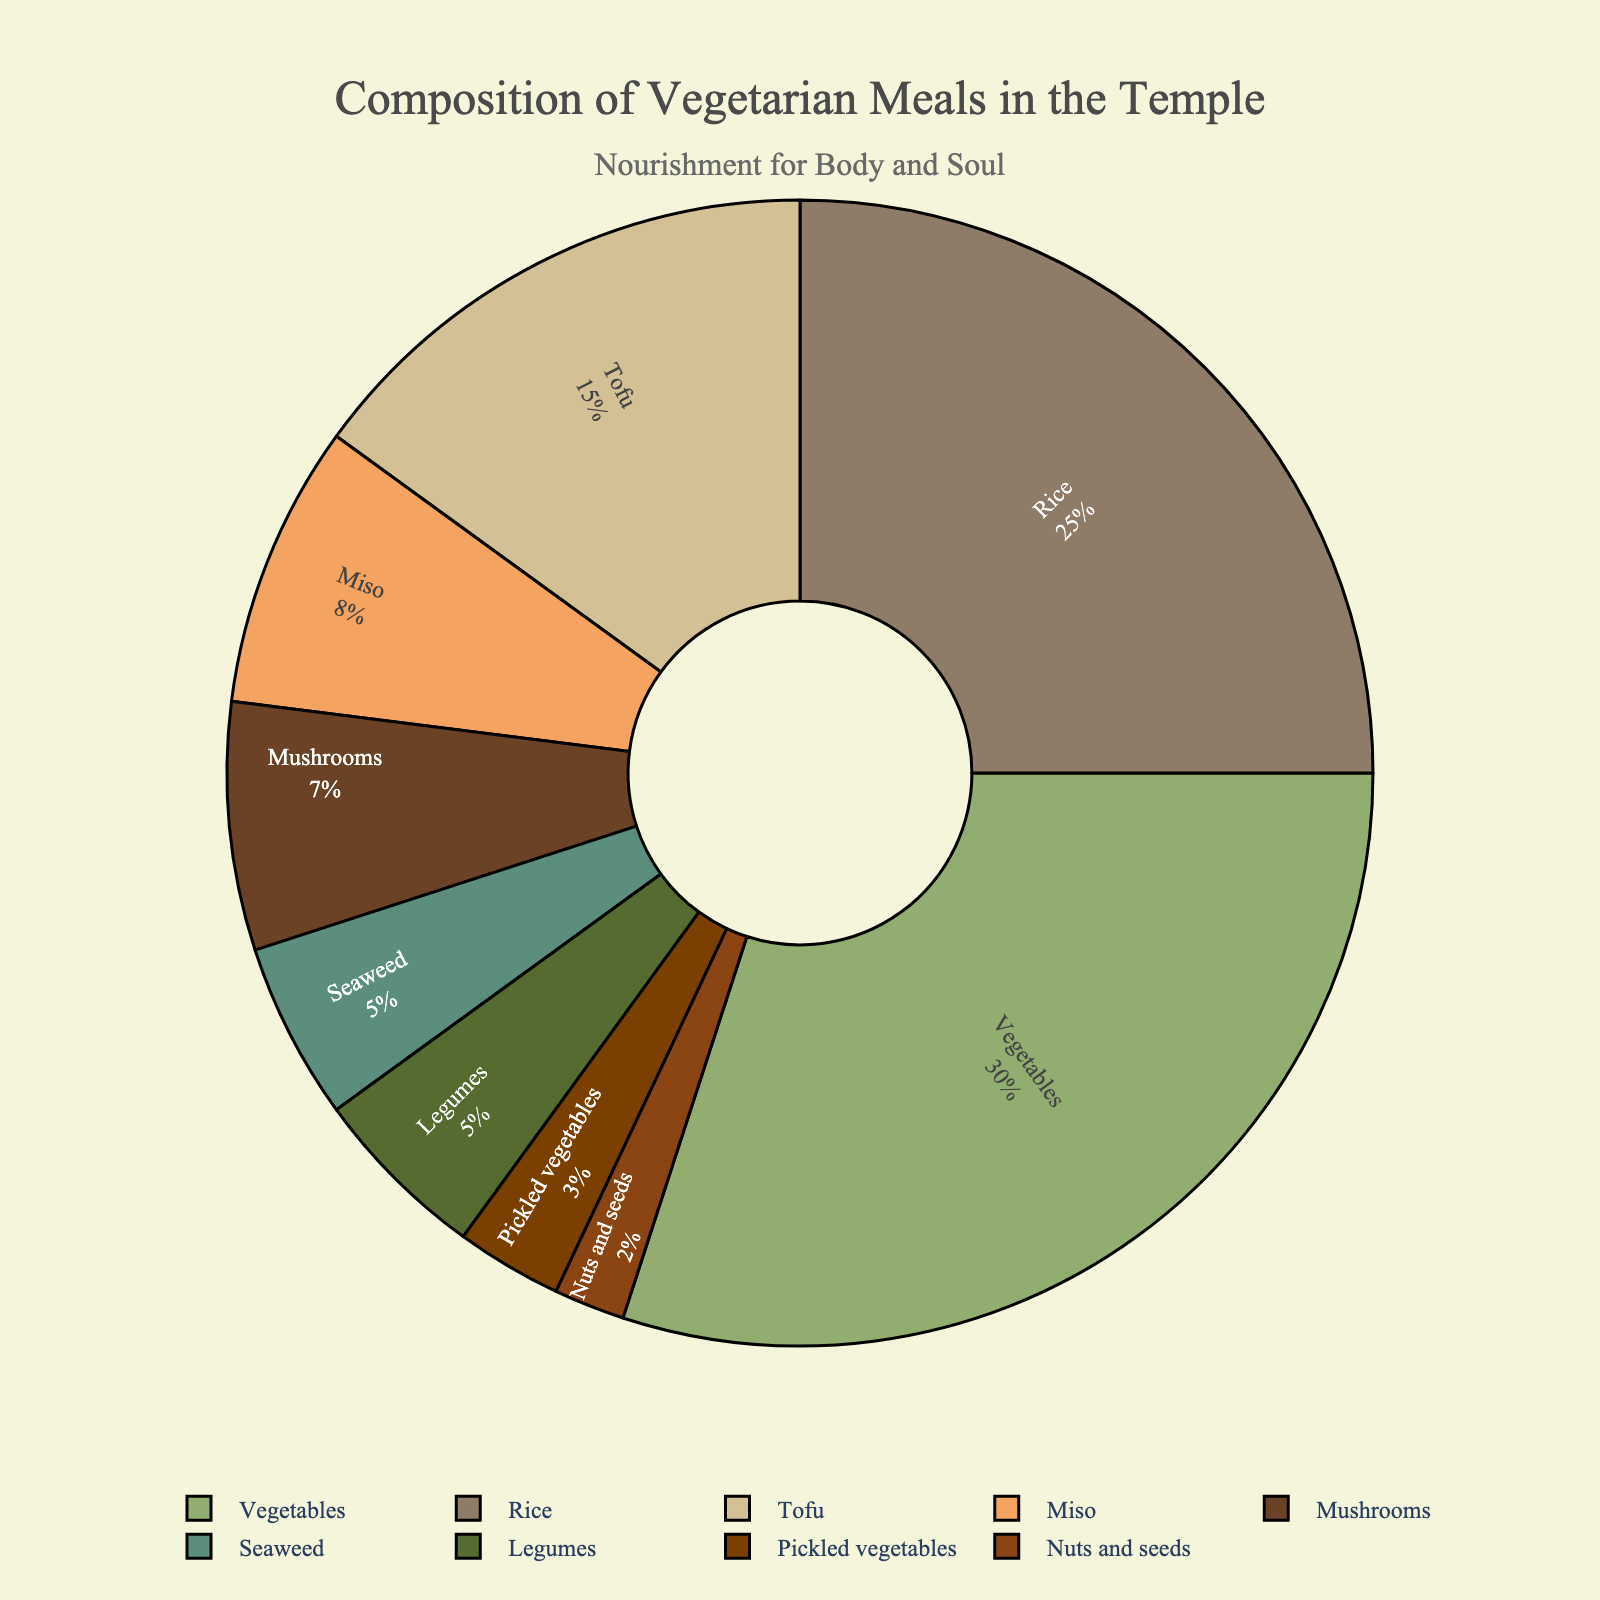What ingredient constitutes the largest portion of vegetarian meals in the temple? The largest portion can be identified by looking at the segment with the highest percentage in the pie chart. The "Vegetables" segment occupies 30%, which is the highest.
Answer: Vegetables Which two ingredients together make up half of the vegetarian meals? By checking the segments, "Vegetables" have 30% and "Rice" has 25%. Adding these together gives 30% + 25% = 55%, which is more than half. However, the most intuitive approach is seeking ones that add close to 50% and they are "Rice" and "Tofu" (25% + 15% = 50%).
Answer: Rice and Tofu What is the difference in the percentage between "Rice" and "Vegetables"? "Rice" constitutes 25%, and "Vegetables" constitute 30%. Subtracting these gives 30% - 25% = 5%.
Answer: 5% Which ingredient has the smallest contribution, and what is its percentage? By identifying the smallest segment in the pie chart, the "Nuts and seeds" segment has the smallest percentage at 2%.
Answer: Nuts and seeds, 2% Are "Seaweed" and "Miso" together making up more or less than 15% of the meals? "Seaweed" makes up 5% and "Miso" makes up 8%. Adding these together gives 5% + 8% = 13%, which is less than 15%.
Answer: Less What is the combined percentage of "Mushrooms" and "Legumes"? "Mushrooms" make up 7%, and "Legumes" make up 5%. Their combined percentage is 7% + 5% = 12%.
Answer: 12% Which ingredient has a higher percentage, "Miso" or "Mushrooms"? Comparing the two segments, "Miso" has 8% and "Mushrooms" have 7%, so "Miso" has a higher percentage.
Answer: Miso Which three ingredients together make up the largest portion of the meals? Checking the top three largest segments: "Vegetables" (30%), "Rice" (25%), and "Tofu" (15%). Their combined contribution is 30% + 25% + 15% = 70%.
Answer: Vegetables, Rice, Tofu What is the percentage contribution of all ingredients except "Vegetables"? All ingredients total 100%. Subtracting the percentage of "Vegetables" (30%) from the total gives 100% - 30% = 70%.
Answer: 70% Compare visually: which ingredient segments are adjacent to the "Rice" segment? Observing the pie chart, the segments directly adjacent to "Rice" are "Tofu" and "Nuts and seeds".
Answer: Tofu and Nuts and seeds 